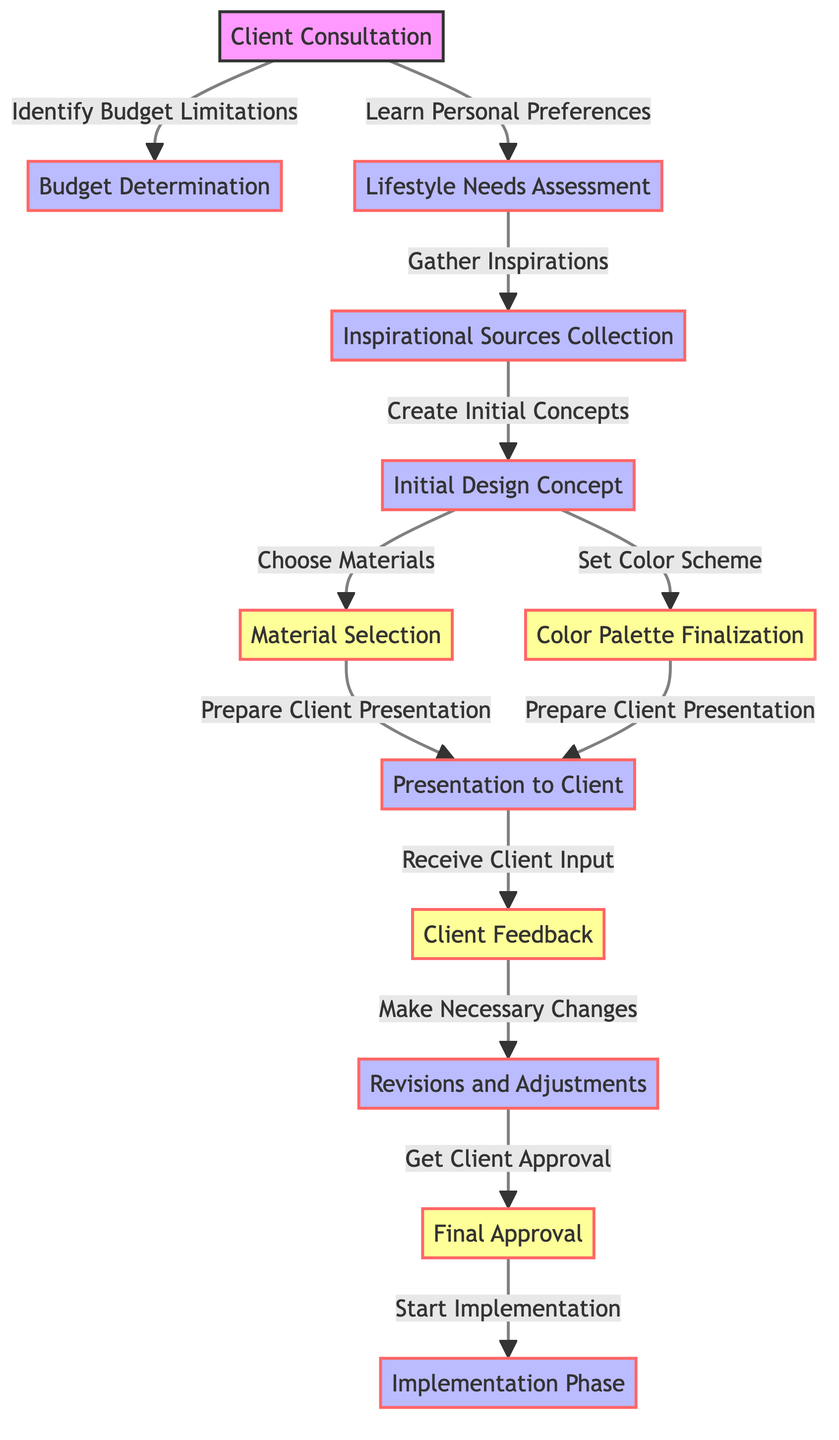What is the first step in the decision-making process? The diagram shows that the first node is "Client Consultation," which is where the process begins.
Answer: Client Consultation How many edges are there in the diagram? Counting each directed line between nodes reveals there are 12 edges connecting 11 nodes.
Answer: 12 What determines the budget in the process? The relationship shows that "Identify Budget Limitations" influences the "Budget Determination" step during the client consultation.
Answer: Identify Budget Limitations Which steps are linked to the presentation to the client? The diagram highlights that "Material Selection" and "Color Palette Finalization" both lead to "Presentation to Client."
Answer: Material Selection, Color Palette Finalization What follows the "Final Approval" in the flow? After "Final Approval," the next step indicated is "Implementation Phase," which shows the continuation of the process.
Answer: Implementation Phase What action occurs after receiving client feedback? According to the flow, the step that follows "Receive Client Input" is "Make Necessary Changes," indicating revisions are required.
Answer: Make Necessary Changes Which two nodes contribute to creating the initial design concept? "Inspirational Sources Collection" leads to "Initial Design Concept," with previous information from "Lifestyle Needs Assessment" also influencing this step.
Answer: Lifestyle Needs Assessment, Inspirational Sources Collection What is the last step in the decision-making process? The final node in the flow indicates that the last step is "Implementation Phase," showing the conclusion of the decision-making framework.
Answer: Implementation Phase How are materials and colors finalized before client presentation? The flowchart shows that "Choose Materials" and "Set Color Scheme" must both be completed before "Prepare Client Presentation," indicating these elements come together prior.
Answer: Choose Materials, Set Color Scheme 